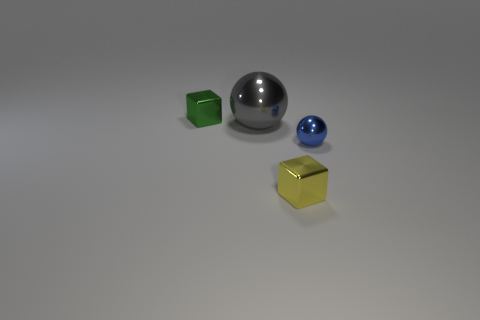The block to the left of the cube in front of the small metallic thing behind the big ball is made of what material?
Offer a very short reply. Metal. How big is the metallic thing that is to the left of the small blue metallic thing and to the right of the big gray object?
Keep it short and to the point. Small. What number of blocks are gray metallic objects or small objects?
Ensure brevity in your answer.  2. What is the color of the metallic sphere that is the same size as the green block?
Keep it short and to the point. Blue. The other large metal object that is the same shape as the blue metallic object is what color?
Provide a succinct answer. Gray. What number of objects are big blue metallic objects or things to the right of the small green block?
Make the answer very short. 3. Is the number of blue metal spheres that are in front of the blue metallic thing less than the number of yellow metal objects?
Your answer should be compact. Yes. There is a cube that is to the left of the cube that is in front of the small thing behind the tiny ball; what is its size?
Your response must be concise. Small. There is a small thing that is both right of the big gray ball and on the left side of the small blue object; what color is it?
Your answer should be very brief. Yellow. What number of small yellow objects are there?
Ensure brevity in your answer.  1. 